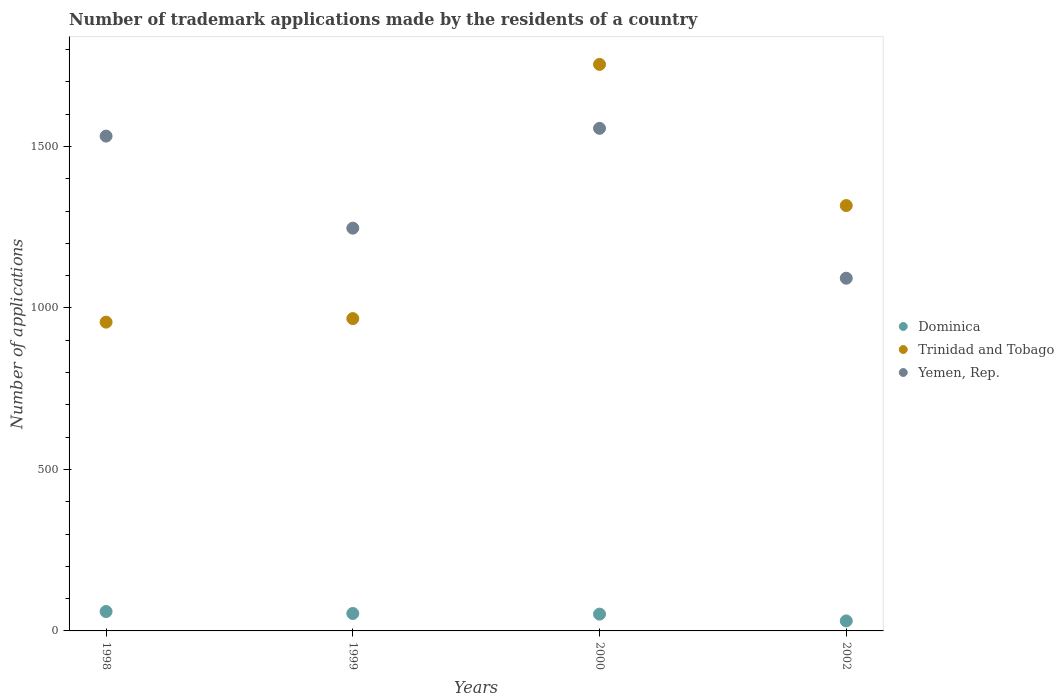What is the number of trademark applications made by the residents in Trinidad and Tobago in 1998?
Your answer should be very brief. 956. Across all years, what is the maximum number of trademark applications made by the residents in Dominica?
Your answer should be very brief. 60. Across all years, what is the minimum number of trademark applications made by the residents in Trinidad and Tobago?
Provide a succinct answer. 956. In which year was the number of trademark applications made by the residents in Yemen, Rep. minimum?
Your answer should be very brief. 2002. What is the total number of trademark applications made by the residents in Dominica in the graph?
Your answer should be compact. 197. What is the difference between the number of trademark applications made by the residents in Yemen, Rep. in 1999 and that in 2000?
Your response must be concise. -309. What is the difference between the number of trademark applications made by the residents in Yemen, Rep. in 2002 and the number of trademark applications made by the residents in Trinidad and Tobago in 2000?
Offer a very short reply. -662. What is the average number of trademark applications made by the residents in Dominica per year?
Provide a succinct answer. 49.25. In the year 1998, what is the difference between the number of trademark applications made by the residents in Trinidad and Tobago and number of trademark applications made by the residents in Yemen, Rep.?
Keep it short and to the point. -576. In how many years, is the number of trademark applications made by the residents in Dominica greater than 1000?
Keep it short and to the point. 0. What is the ratio of the number of trademark applications made by the residents in Trinidad and Tobago in 1999 to that in 2002?
Offer a terse response. 0.73. What is the difference between the highest and the second highest number of trademark applications made by the residents in Yemen, Rep.?
Your answer should be compact. 24. In how many years, is the number of trademark applications made by the residents in Trinidad and Tobago greater than the average number of trademark applications made by the residents in Trinidad and Tobago taken over all years?
Provide a short and direct response. 2. Is the sum of the number of trademark applications made by the residents in Trinidad and Tobago in 1999 and 2002 greater than the maximum number of trademark applications made by the residents in Dominica across all years?
Give a very brief answer. Yes. Does the number of trademark applications made by the residents in Yemen, Rep. monotonically increase over the years?
Offer a very short reply. No. Is the number of trademark applications made by the residents in Yemen, Rep. strictly greater than the number of trademark applications made by the residents in Trinidad and Tobago over the years?
Your answer should be compact. No. Is the number of trademark applications made by the residents in Yemen, Rep. strictly less than the number of trademark applications made by the residents in Dominica over the years?
Keep it short and to the point. No. What is the difference between two consecutive major ticks on the Y-axis?
Offer a terse response. 500. Does the graph contain any zero values?
Offer a terse response. No. Does the graph contain grids?
Ensure brevity in your answer.  No. Where does the legend appear in the graph?
Provide a succinct answer. Center right. How many legend labels are there?
Make the answer very short. 3. How are the legend labels stacked?
Ensure brevity in your answer.  Vertical. What is the title of the graph?
Offer a very short reply. Number of trademark applications made by the residents of a country. What is the label or title of the Y-axis?
Offer a terse response. Number of applications. What is the Number of applications in Dominica in 1998?
Your answer should be compact. 60. What is the Number of applications in Trinidad and Tobago in 1998?
Your response must be concise. 956. What is the Number of applications of Yemen, Rep. in 1998?
Offer a very short reply. 1532. What is the Number of applications in Dominica in 1999?
Provide a short and direct response. 54. What is the Number of applications in Trinidad and Tobago in 1999?
Your answer should be compact. 967. What is the Number of applications of Yemen, Rep. in 1999?
Your answer should be compact. 1247. What is the Number of applications in Trinidad and Tobago in 2000?
Your response must be concise. 1754. What is the Number of applications of Yemen, Rep. in 2000?
Ensure brevity in your answer.  1556. What is the Number of applications of Dominica in 2002?
Your response must be concise. 31. What is the Number of applications in Trinidad and Tobago in 2002?
Offer a very short reply. 1317. What is the Number of applications in Yemen, Rep. in 2002?
Provide a short and direct response. 1092. Across all years, what is the maximum Number of applications of Dominica?
Your answer should be compact. 60. Across all years, what is the maximum Number of applications of Trinidad and Tobago?
Ensure brevity in your answer.  1754. Across all years, what is the maximum Number of applications of Yemen, Rep.?
Your answer should be very brief. 1556. Across all years, what is the minimum Number of applications of Trinidad and Tobago?
Make the answer very short. 956. Across all years, what is the minimum Number of applications of Yemen, Rep.?
Your answer should be compact. 1092. What is the total Number of applications of Dominica in the graph?
Offer a very short reply. 197. What is the total Number of applications of Trinidad and Tobago in the graph?
Offer a terse response. 4994. What is the total Number of applications in Yemen, Rep. in the graph?
Offer a terse response. 5427. What is the difference between the Number of applications in Dominica in 1998 and that in 1999?
Provide a succinct answer. 6. What is the difference between the Number of applications in Yemen, Rep. in 1998 and that in 1999?
Make the answer very short. 285. What is the difference between the Number of applications in Dominica in 1998 and that in 2000?
Provide a short and direct response. 8. What is the difference between the Number of applications in Trinidad and Tobago in 1998 and that in 2000?
Ensure brevity in your answer.  -798. What is the difference between the Number of applications in Trinidad and Tobago in 1998 and that in 2002?
Provide a short and direct response. -361. What is the difference between the Number of applications in Yemen, Rep. in 1998 and that in 2002?
Offer a very short reply. 440. What is the difference between the Number of applications in Dominica in 1999 and that in 2000?
Your response must be concise. 2. What is the difference between the Number of applications in Trinidad and Tobago in 1999 and that in 2000?
Ensure brevity in your answer.  -787. What is the difference between the Number of applications in Yemen, Rep. in 1999 and that in 2000?
Make the answer very short. -309. What is the difference between the Number of applications of Trinidad and Tobago in 1999 and that in 2002?
Keep it short and to the point. -350. What is the difference between the Number of applications in Yemen, Rep. in 1999 and that in 2002?
Your response must be concise. 155. What is the difference between the Number of applications of Trinidad and Tobago in 2000 and that in 2002?
Provide a short and direct response. 437. What is the difference between the Number of applications of Yemen, Rep. in 2000 and that in 2002?
Your answer should be very brief. 464. What is the difference between the Number of applications of Dominica in 1998 and the Number of applications of Trinidad and Tobago in 1999?
Make the answer very short. -907. What is the difference between the Number of applications of Dominica in 1998 and the Number of applications of Yemen, Rep. in 1999?
Your response must be concise. -1187. What is the difference between the Number of applications of Trinidad and Tobago in 1998 and the Number of applications of Yemen, Rep. in 1999?
Give a very brief answer. -291. What is the difference between the Number of applications in Dominica in 1998 and the Number of applications in Trinidad and Tobago in 2000?
Ensure brevity in your answer.  -1694. What is the difference between the Number of applications in Dominica in 1998 and the Number of applications in Yemen, Rep. in 2000?
Ensure brevity in your answer.  -1496. What is the difference between the Number of applications in Trinidad and Tobago in 1998 and the Number of applications in Yemen, Rep. in 2000?
Provide a succinct answer. -600. What is the difference between the Number of applications in Dominica in 1998 and the Number of applications in Trinidad and Tobago in 2002?
Give a very brief answer. -1257. What is the difference between the Number of applications in Dominica in 1998 and the Number of applications in Yemen, Rep. in 2002?
Provide a succinct answer. -1032. What is the difference between the Number of applications in Trinidad and Tobago in 1998 and the Number of applications in Yemen, Rep. in 2002?
Your answer should be compact. -136. What is the difference between the Number of applications in Dominica in 1999 and the Number of applications in Trinidad and Tobago in 2000?
Ensure brevity in your answer.  -1700. What is the difference between the Number of applications of Dominica in 1999 and the Number of applications of Yemen, Rep. in 2000?
Give a very brief answer. -1502. What is the difference between the Number of applications in Trinidad and Tobago in 1999 and the Number of applications in Yemen, Rep. in 2000?
Offer a very short reply. -589. What is the difference between the Number of applications in Dominica in 1999 and the Number of applications in Trinidad and Tobago in 2002?
Offer a terse response. -1263. What is the difference between the Number of applications in Dominica in 1999 and the Number of applications in Yemen, Rep. in 2002?
Make the answer very short. -1038. What is the difference between the Number of applications in Trinidad and Tobago in 1999 and the Number of applications in Yemen, Rep. in 2002?
Ensure brevity in your answer.  -125. What is the difference between the Number of applications of Dominica in 2000 and the Number of applications of Trinidad and Tobago in 2002?
Your response must be concise. -1265. What is the difference between the Number of applications in Dominica in 2000 and the Number of applications in Yemen, Rep. in 2002?
Your response must be concise. -1040. What is the difference between the Number of applications in Trinidad and Tobago in 2000 and the Number of applications in Yemen, Rep. in 2002?
Keep it short and to the point. 662. What is the average Number of applications of Dominica per year?
Keep it short and to the point. 49.25. What is the average Number of applications in Trinidad and Tobago per year?
Give a very brief answer. 1248.5. What is the average Number of applications in Yemen, Rep. per year?
Provide a short and direct response. 1356.75. In the year 1998, what is the difference between the Number of applications of Dominica and Number of applications of Trinidad and Tobago?
Give a very brief answer. -896. In the year 1998, what is the difference between the Number of applications of Dominica and Number of applications of Yemen, Rep.?
Provide a succinct answer. -1472. In the year 1998, what is the difference between the Number of applications of Trinidad and Tobago and Number of applications of Yemen, Rep.?
Your response must be concise. -576. In the year 1999, what is the difference between the Number of applications in Dominica and Number of applications in Trinidad and Tobago?
Offer a very short reply. -913. In the year 1999, what is the difference between the Number of applications in Dominica and Number of applications in Yemen, Rep.?
Offer a very short reply. -1193. In the year 1999, what is the difference between the Number of applications of Trinidad and Tobago and Number of applications of Yemen, Rep.?
Your response must be concise. -280. In the year 2000, what is the difference between the Number of applications of Dominica and Number of applications of Trinidad and Tobago?
Make the answer very short. -1702. In the year 2000, what is the difference between the Number of applications of Dominica and Number of applications of Yemen, Rep.?
Keep it short and to the point. -1504. In the year 2000, what is the difference between the Number of applications of Trinidad and Tobago and Number of applications of Yemen, Rep.?
Offer a very short reply. 198. In the year 2002, what is the difference between the Number of applications of Dominica and Number of applications of Trinidad and Tobago?
Keep it short and to the point. -1286. In the year 2002, what is the difference between the Number of applications of Dominica and Number of applications of Yemen, Rep.?
Offer a very short reply. -1061. In the year 2002, what is the difference between the Number of applications in Trinidad and Tobago and Number of applications in Yemen, Rep.?
Your response must be concise. 225. What is the ratio of the Number of applications in Trinidad and Tobago in 1998 to that in 1999?
Your answer should be very brief. 0.99. What is the ratio of the Number of applications of Yemen, Rep. in 1998 to that in 1999?
Your answer should be very brief. 1.23. What is the ratio of the Number of applications in Dominica in 1998 to that in 2000?
Ensure brevity in your answer.  1.15. What is the ratio of the Number of applications in Trinidad and Tobago in 1998 to that in 2000?
Provide a succinct answer. 0.55. What is the ratio of the Number of applications in Yemen, Rep. in 1998 to that in 2000?
Your answer should be very brief. 0.98. What is the ratio of the Number of applications of Dominica in 1998 to that in 2002?
Offer a terse response. 1.94. What is the ratio of the Number of applications in Trinidad and Tobago in 1998 to that in 2002?
Give a very brief answer. 0.73. What is the ratio of the Number of applications in Yemen, Rep. in 1998 to that in 2002?
Your answer should be compact. 1.4. What is the ratio of the Number of applications in Dominica in 1999 to that in 2000?
Give a very brief answer. 1.04. What is the ratio of the Number of applications of Trinidad and Tobago in 1999 to that in 2000?
Ensure brevity in your answer.  0.55. What is the ratio of the Number of applications of Yemen, Rep. in 1999 to that in 2000?
Offer a very short reply. 0.8. What is the ratio of the Number of applications of Dominica in 1999 to that in 2002?
Give a very brief answer. 1.74. What is the ratio of the Number of applications in Trinidad and Tobago in 1999 to that in 2002?
Offer a very short reply. 0.73. What is the ratio of the Number of applications of Yemen, Rep. in 1999 to that in 2002?
Offer a terse response. 1.14. What is the ratio of the Number of applications of Dominica in 2000 to that in 2002?
Your answer should be very brief. 1.68. What is the ratio of the Number of applications in Trinidad and Tobago in 2000 to that in 2002?
Provide a succinct answer. 1.33. What is the ratio of the Number of applications in Yemen, Rep. in 2000 to that in 2002?
Offer a very short reply. 1.42. What is the difference between the highest and the second highest Number of applications in Trinidad and Tobago?
Offer a terse response. 437. What is the difference between the highest and the lowest Number of applications in Trinidad and Tobago?
Your response must be concise. 798. What is the difference between the highest and the lowest Number of applications of Yemen, Rep.?
Keep it short and to the point. 464. 